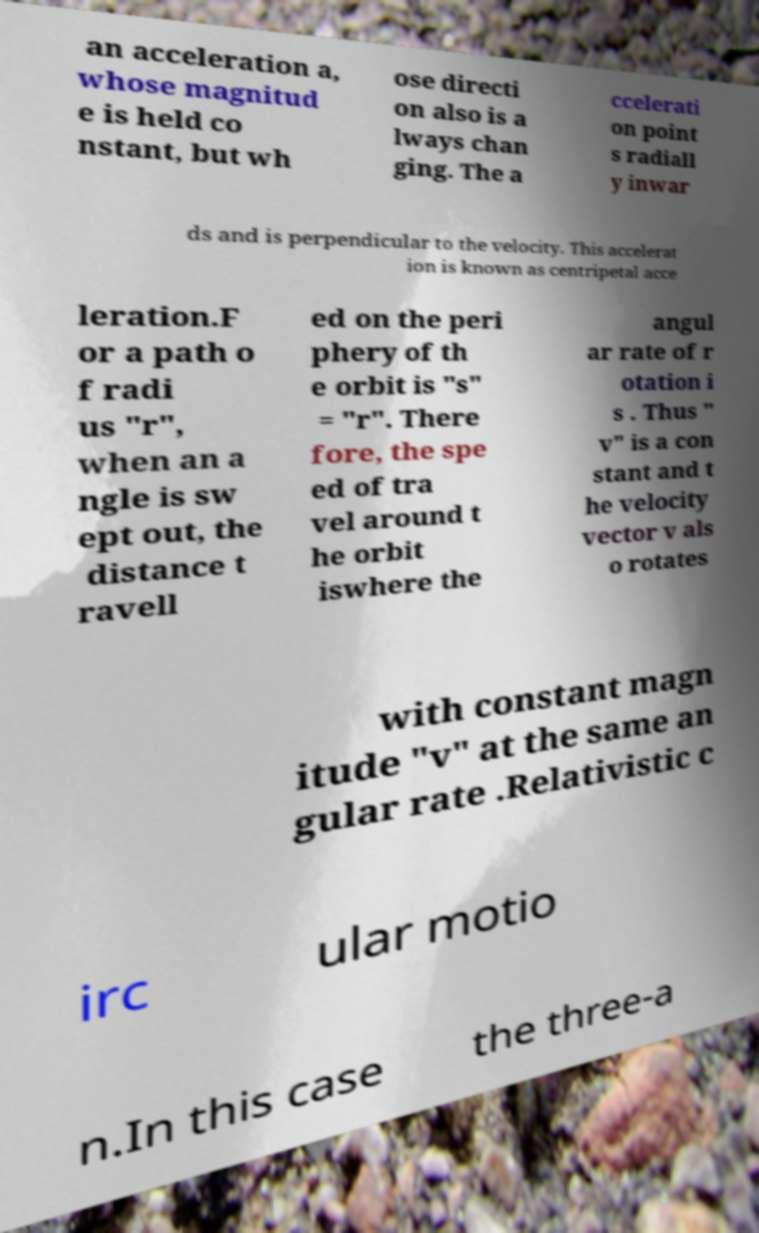Please read and relay the text visible in this image. What does it say? an acceleration a, whose magnitud e is held co nstant, but wh ose directi on also is a lways chan ging. The a ccelerati on point s radiall y inwar ds and is perpendicular to the velocity. This accelerat ion is known as centripetal acce leration.F or a path o f radi us "r", when an a ngle is sw ept out, the distance t ravell ed on the peri phery of th e orbit is "s" = "r". There fore, the spe ed of tra vel around t he orbit iswhere the angul ar rate of r otation i s . Thus " v" is a con stant and t he velocity vector v als o rotates with constant magn itude "v" at the same an gular rate .Relativistic c irc ular motio n.In this case the three-a 